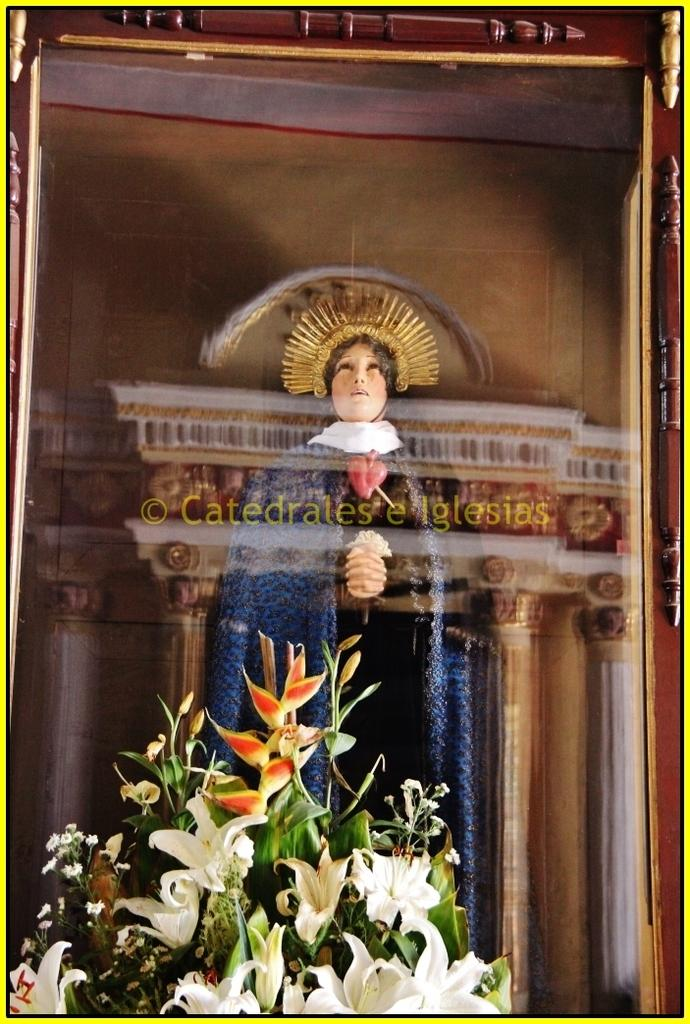What type of plants can be seen in the image? There are flowers in the image. What object is present that might hold a picture or memory? There is a photo frame in the image. Who is present in the image? There is a woman standing in the image. What type of pencil can be seen in the image? There is no pencil present in the image. How many tickets are visible in the image? There are no tickets visible in the image. 